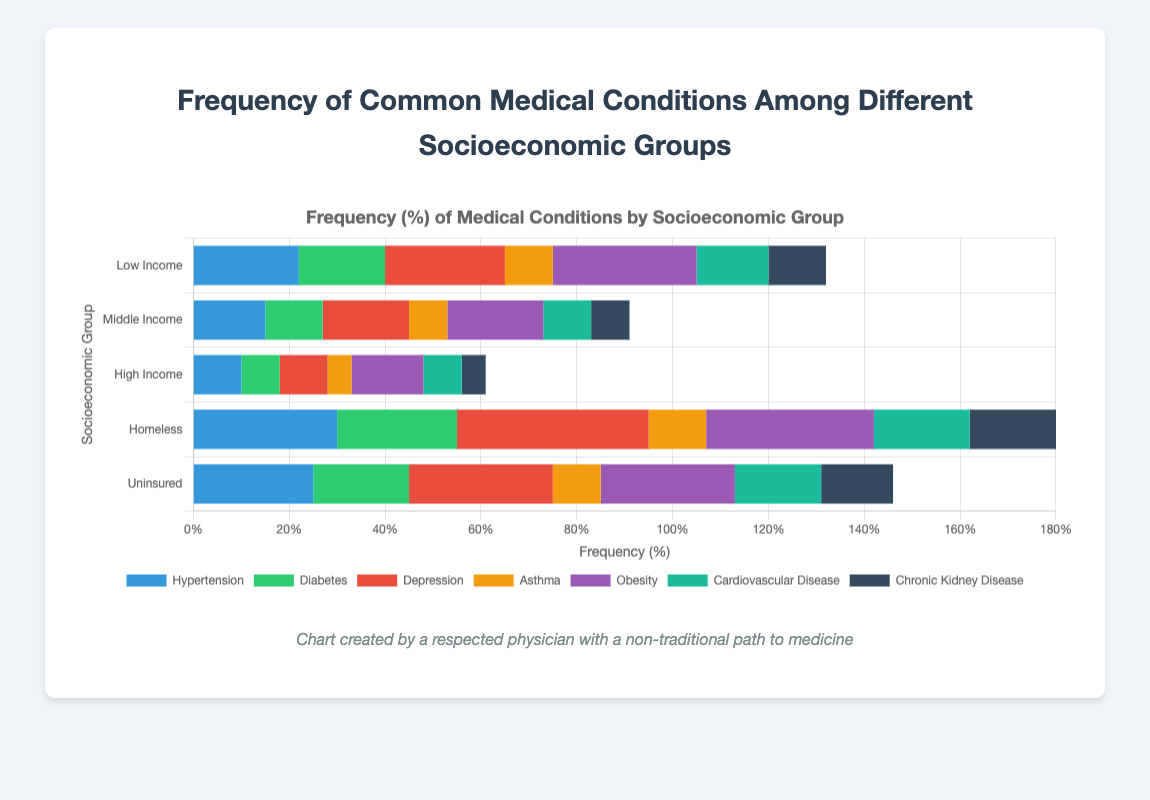What's the most common medical condition among homeless people? By looking at the tallest bar segment for the "Homeless" group, we see that the red bar representing "Depression" is the longest.
Answer: Depression How does the frequency of diabetes in uninsured people compare to that in middle-income people? The green bar for "Diabetes" in the "Uninsured" group is longer than the corresponding bar in the "Middle Income" group. Specifically, it shows 20% for uninsured and 12% for middle income.
Answer: Higher Which group has the lowest frequency of hypertension? By comparing the blue bars for "Hypertension" across all groups, the "High Income" group has the shortest bar, representing a 10% frequency.
Answer: High Income What's the total frequency of asthma and obesity in low-income people? The orange bar for "Asthma" shows 10%, and the purple bar for "Obesity" shows 30%. Adding these together gives a total of 40%.
Answer: 40% Compare the frequency of hypertension between low-income and homeless people. The blue bar for "Hypertension" is at 22% for low-income and 30% for homeless individuals, indicating a higher prevalence in the homeless group.
Answer: Greater in Homeless What is the second most common medical condition in low-income people? The longest bars represent the most frequent conditions. After "Obesity" (30%), the second longest bar is red for "Depression" at 25%.
Answer: Depression What is the sum of frequencies of cardiovascular disease and chronic kidney disease among the homeless population? The teal bar for "Cardiovascular Disease" shows 20%, while the dark gray bar for "Chronic Kidney Disease" shows 18%. Summing these frequencies gives 38%.
Answer: 38% Which condition has the least variation in frequency across all groups? By visually comparing the length of all bars for each condition across the groups, "Asthma" seems to have the least variation in height.
Answer: Asthma What's the difference in frequency of obesity between middle-income and high-income groups? The purple bar for "Obesity" is 20% in the middle-income group and 15% in the high-income group, giving a difference of 5%.
Answer: 5% What is the average frequency of depression across all socioeconomic groups? The frequencies for "Depression" are: 25%, 18%, 10%, 40%, and 30%. Summing these gives 123%, and dividing by 5 gives an average of 24.6%.
Answer: 24.6% 